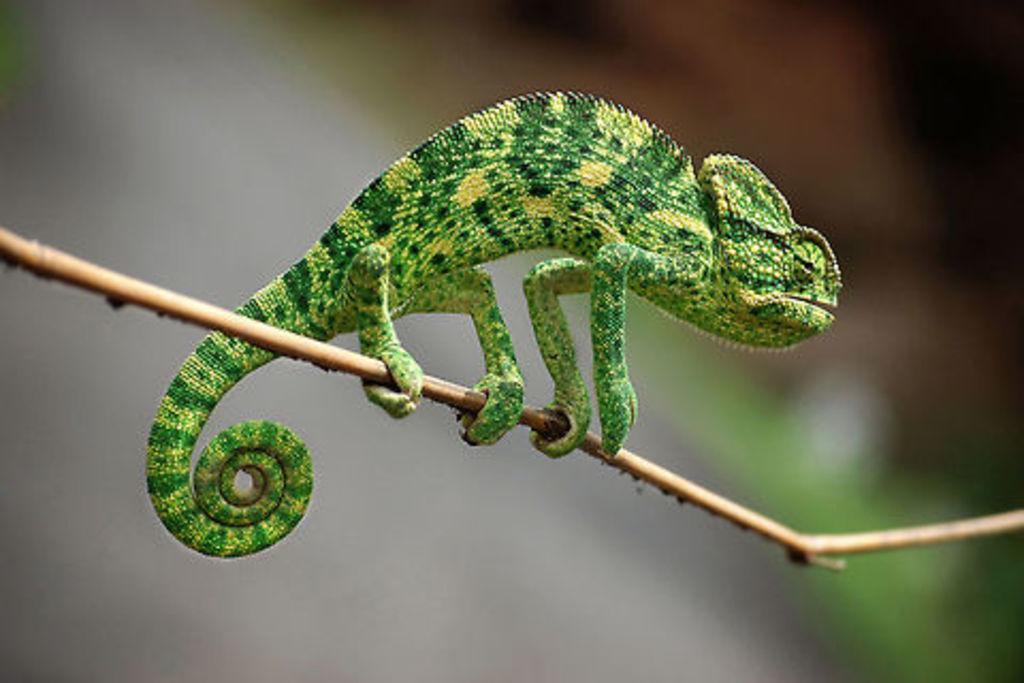Describe this image in one or two sentences. In this image, we can see a chameleon on the stick. In the background image is blurred. 